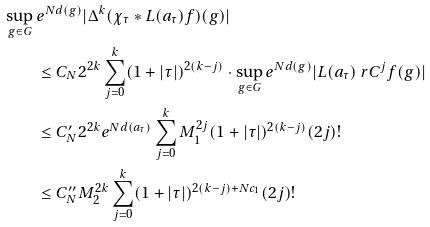<formula> <loc_0><loc_0><loc_500><loc_500>\sup _ { g \in G } \, & e ^ { N d ( g ) } | \Delta ^ { k } ( \chi _ { \tau } * L ( a _ { \tau } ) f ) ( g ) | \\ & \leq C _ { N } 2 ^ { 2 k } \sum _ { j = 0 } ^ { k } ( 1 + | \tau | ) ^ { 2 ( k - j ) } \cdot \sup _ { g \in G } e ^ { N d ( g ) } | L ( a _ { \tau } ) \ r C ^ { j } f ( g ) | \\ & \leq C _ { N } ^ { \prime } 2 ^ { 2 k } e ^ { N d ( a _ { \tau } ) } \sum _ { j = 0 } ^ { k } M _ { 1 } ^ { 2 j } ( 1 + | \tau | ) ^ { 2 ( k - j ) } ( 2 j ) ! \\ & \leq C _ { N } ^ { \prime \prime } M _ { 2 } ^ { 2 k } \sum _ { j = 0 } ^ { k } ( 1 + | \tau | ) ^ { 2 ( k - j ) + N c _ { 1 } } ( 2 j ) !</formula> 